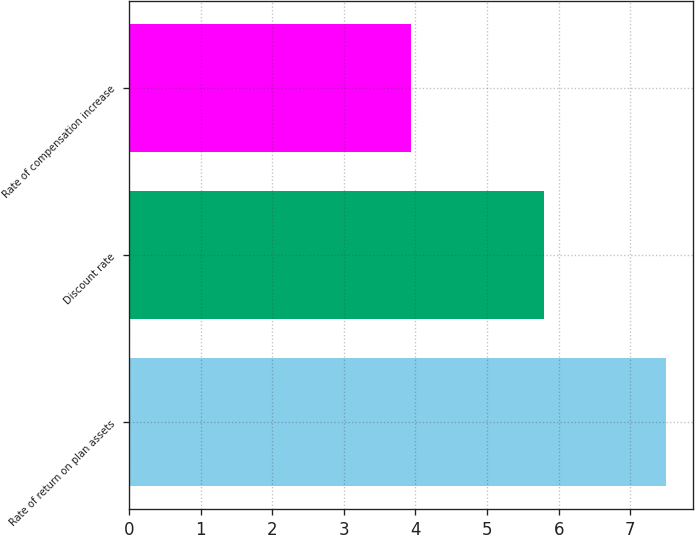<chart> <loc_0><loc_0><loc_500><loc_500><bar_chart><fcel>Rate of return on plan assets<fcel>Discount rate<fcel>Rate of compensation increase<nl><fcel>7.5<fcel>5.79<fcel>3.94<nl></chart> 